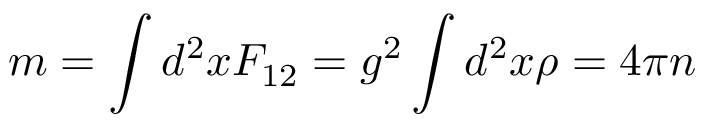Convert formula to latex. <formula><loc_0><loc_0><loc_500><loc_500>m = \int d ^ { 2 } x F _ { 1 2 } = g ^ { 2 } \int d ^ { 2 } x \rho = 4 \pi n</formula> 